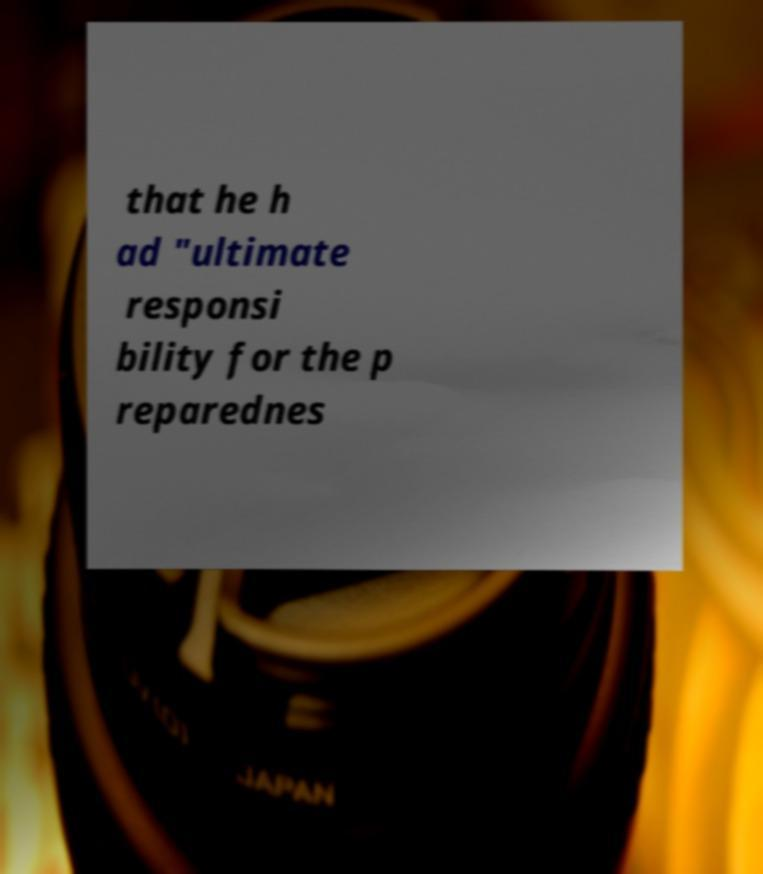There's text embedded in this image that I need extracted. Can you transcribe it verbatim? that he h ad "ultimate responsi bility for the p reparednes 